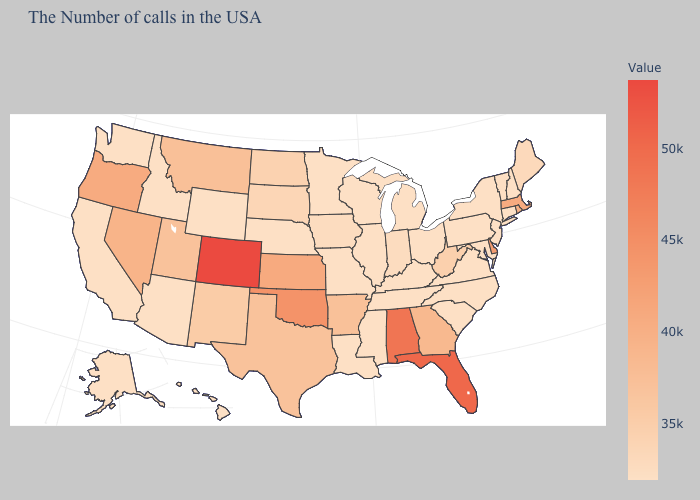Which states hav the highest value in the MidWest?
Concise answer only. Kansas. Is the legend a continuous bar?
Concise answer only. Yes. Does South Carolina have the highest value in the USA?
Be succinct. No. Among the states that border South Carolina , does Georgia have the highest value?
Concise answer only. Yes. 